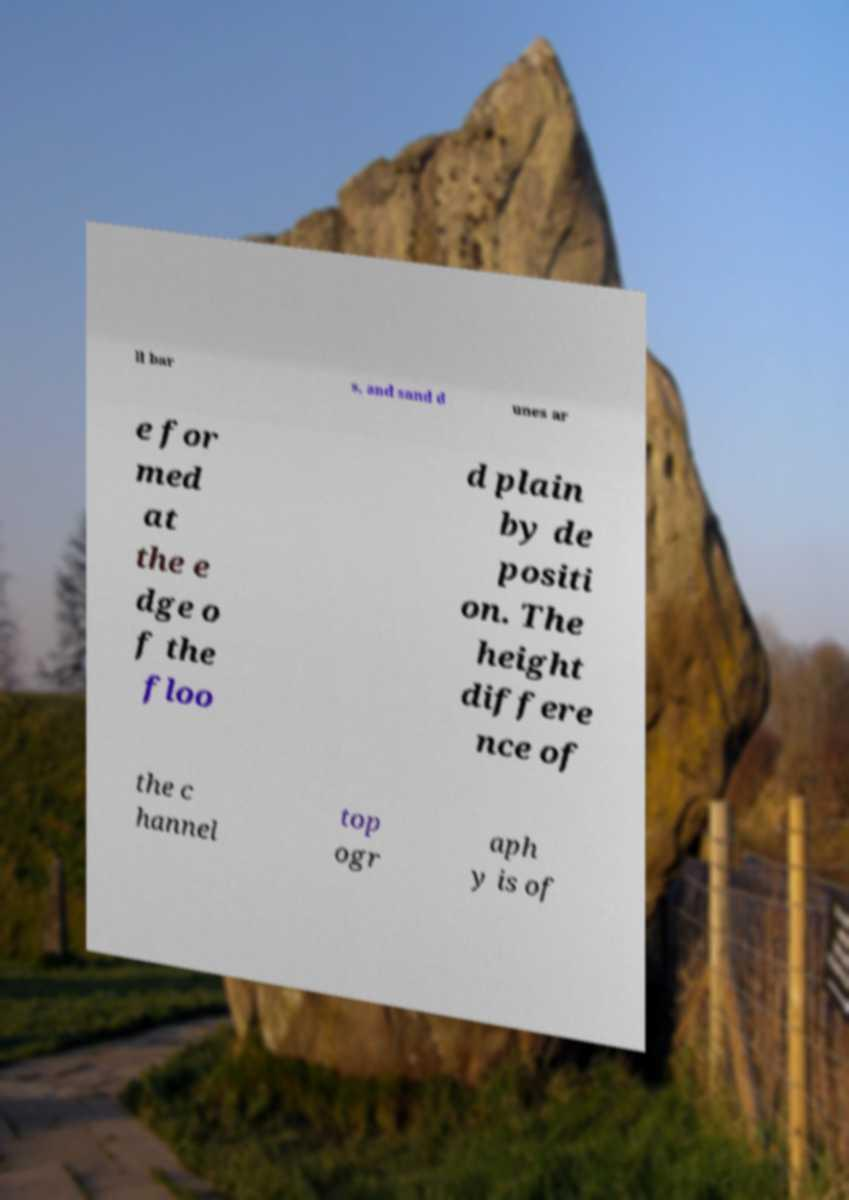Can you accurately transcribe the text from the provided image for me? ll bar s, and sand d unes ar e for med at the e dge o f the floo d plain by de positi on. The height differe nce of the c hannel top ogr aph y is of 